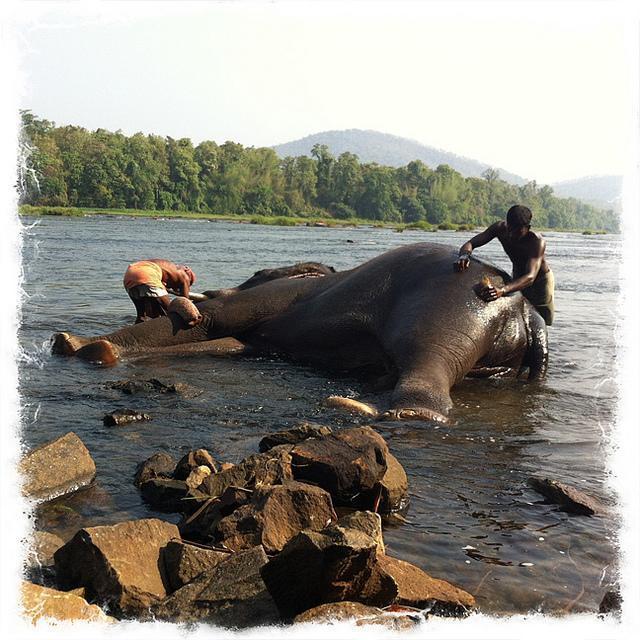How many people are in the picture?
Give a very brief answer. 2. 